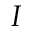<formula> <loc_0><loc_0><loc_500><loc_500>I</formula> 